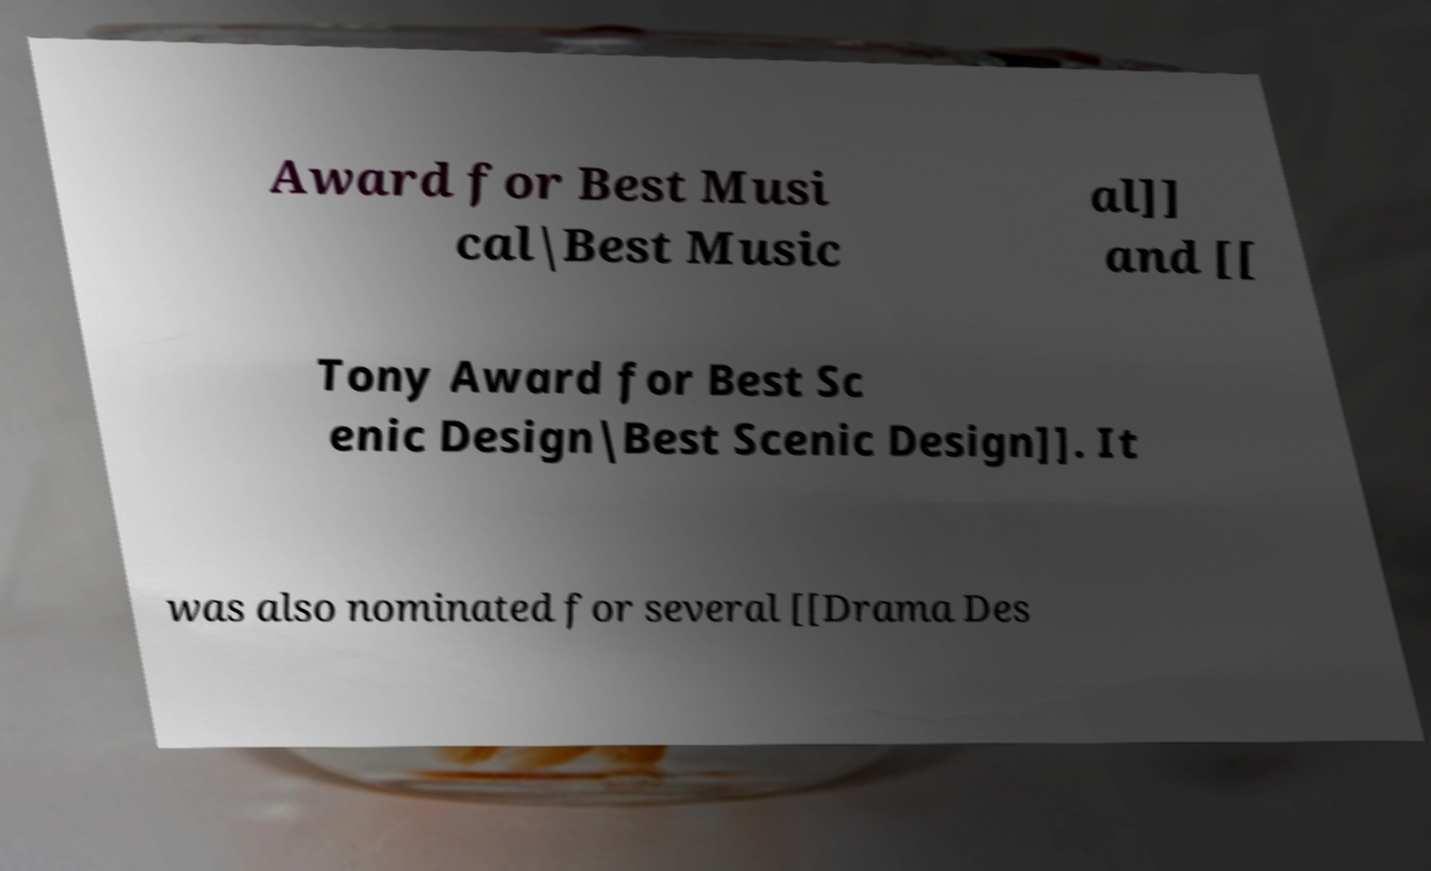Please identify and transcribe the text found in this image. Award for Best Musi cal|Best Music al]] and [[ Tony Award for Best Sc enic Design|Best Scenic Design]]. It was also nominated for several [[Drama Des 